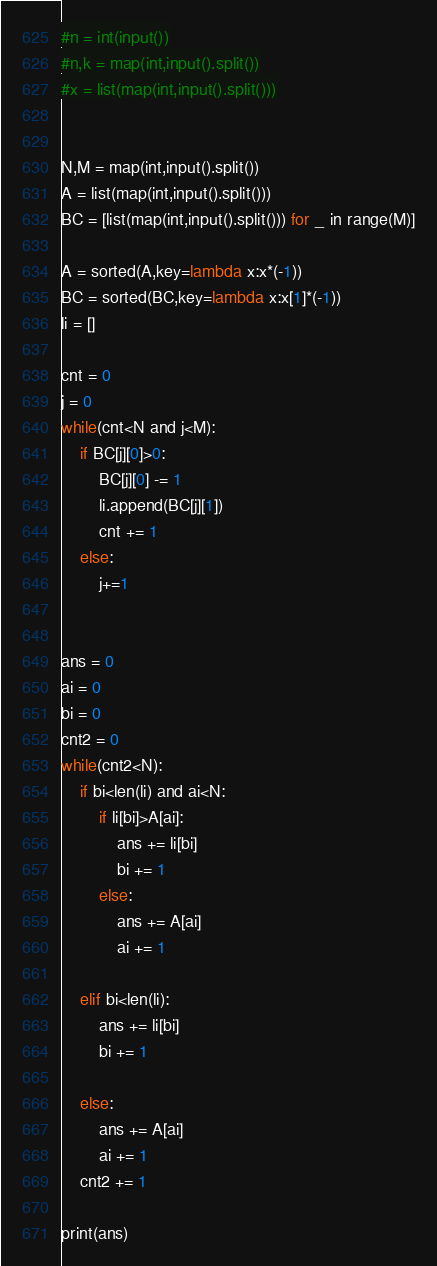<code> <loc_0><loc_0><loc_500><loc_500><_Python_>#n = int(input())
#n,k = map(int,input().split())
#x = list(map(int,input().split()))


N,M = map(int,input().split())
A = list(map(int,input().split()))
BC = [list(map(int,input().split())) for _ in range(M)]

A = sorted(A,key=lambda x:x*(-1))
BC = sorted(BC,key=lambda x:x[1]*(-1))
li = []

cnt = 0
j = 0
while(cnt<N and j<M):
    if BC[j][0]>0:
        BC[j][0] -= 1
        li.append(BC[j][1])
        cnt += 1
    else:
        j+=1
    

ans = 0
ai = 0
bi = 0
cnt2 = 0
while(cnt2<N):
    if bi<len(li) and ai<N:
        if li[bi]>A[ai]:
            ans += li[bi]
            bi += 1
        else:
            ans += A[ai]
            ai += 1
    
    elif bi<len(li):
        ans += li[bi]
        bi += 1

    else:
        ans += A[ai]
        ai += 1
    cnt2 += 1

print(ans)
</code> 